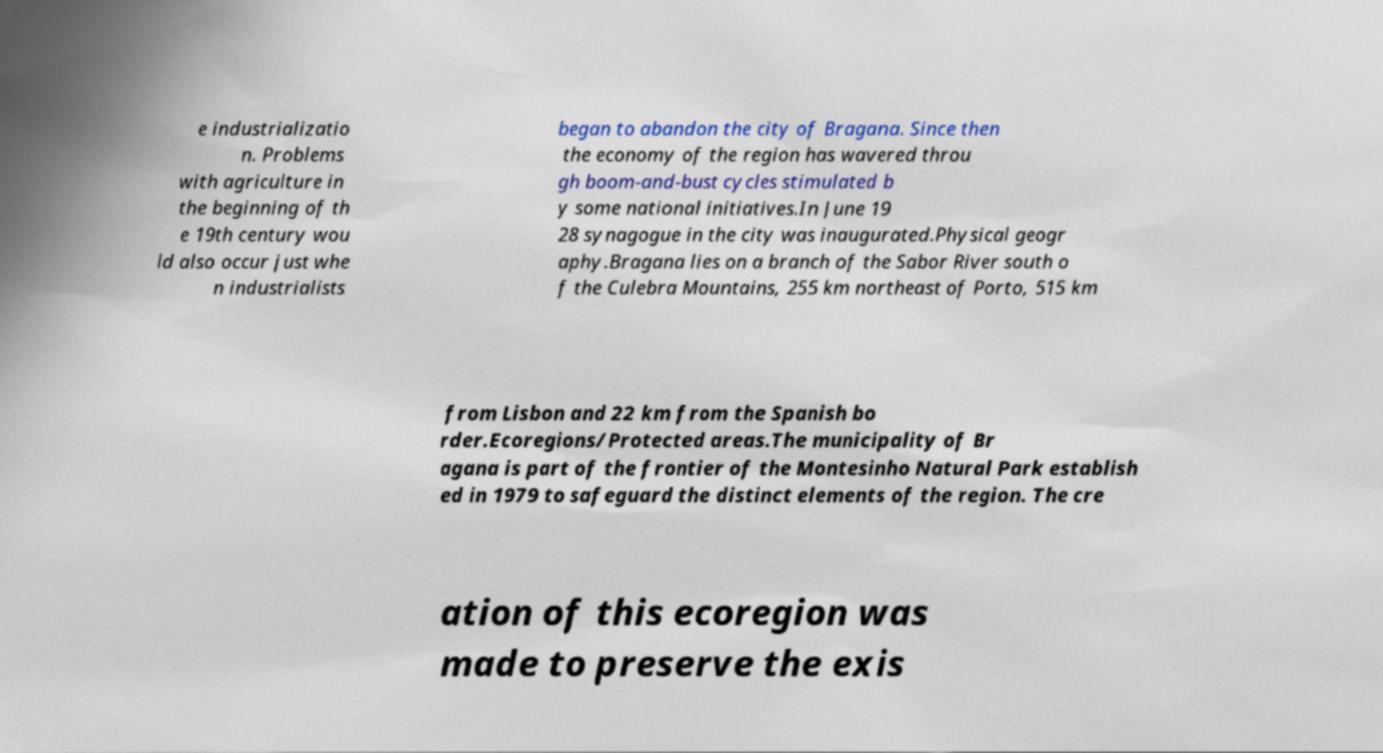Please read and relay the text visible in this image. What does it say? e industrializatio n. Problems with agriculture in the beginning of th e 19th century wou ld also occur just whe n industrialists began to abandon the city of Bragana. Since then the economy of the region has wavered throu gh boom-and-bust cycles stimulated b y some national initiatives.In June 19 28 synagogue in the city was inaugurated.Physical geogr aphy.Bragana lies on a branch of the Sabor River south o f the Culebra Mountains, 255 km northeast of Porto, 515 km from Lisbon and 22 km from the Spanish bo rder.Ecoregions/Protected areas.The municipality of Br agana is part of the frontier of the Montesinho Natural Park establish ed in 1979 to safeguard the distinct elements of the region. The cre ation of this ecoregion was made to preserve the exis 